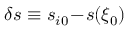Convert formula to latex. <formula><loc_0><loc_0><loc_500><loc_500>\delta s \equiv s _ { i 0 } \, - \, s ( \xi _ { 0 } )</formula> 